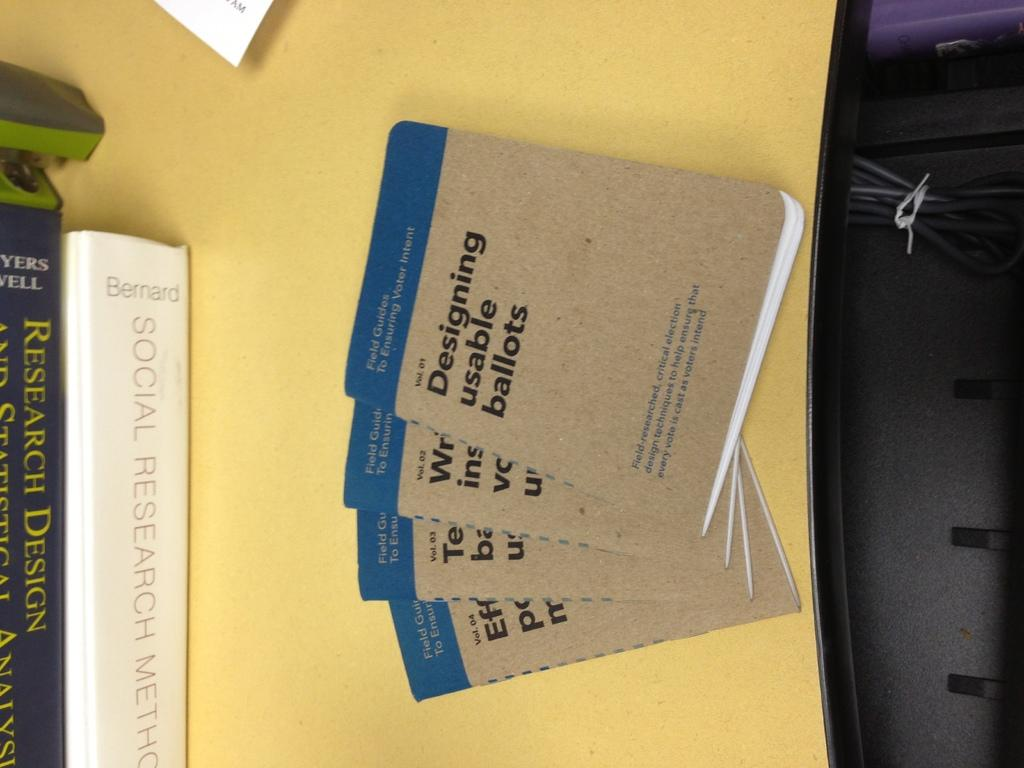<image>
Write a terse but informative summary of the picture. A number of handbooks from the series Field Guides to Ensuring Voter Intent. 